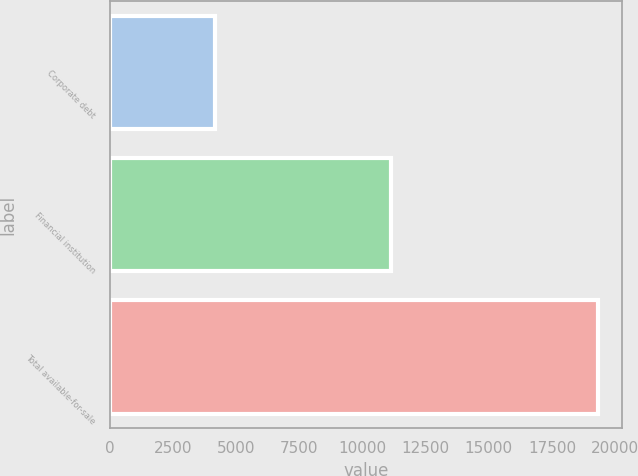Convert chart to OTSL. <chart><loc_0><loc_0><loc_500><loc_500><bar_chart><fcel>Corporate debt<fcel>Financial institution<fcel>Total available-for-sale<nl><fcel>4169<fcel>11140<fcel>19311<nl></chart> 